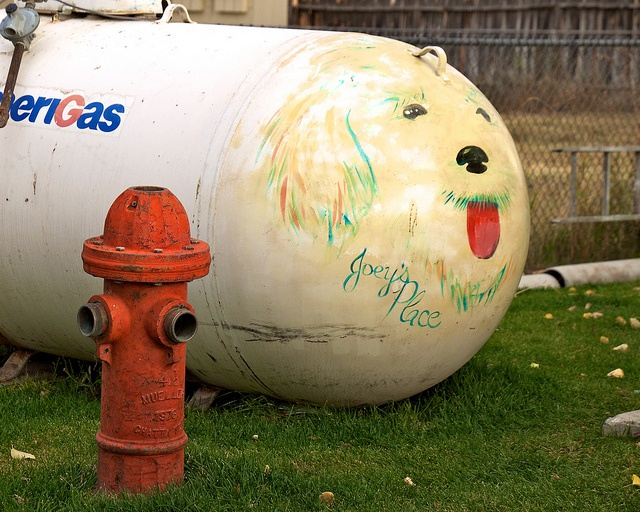Describe the objects in this image and their specific colors. I can see a fire hydrant in tan, brown, maroon, red, and black tones in this image. 